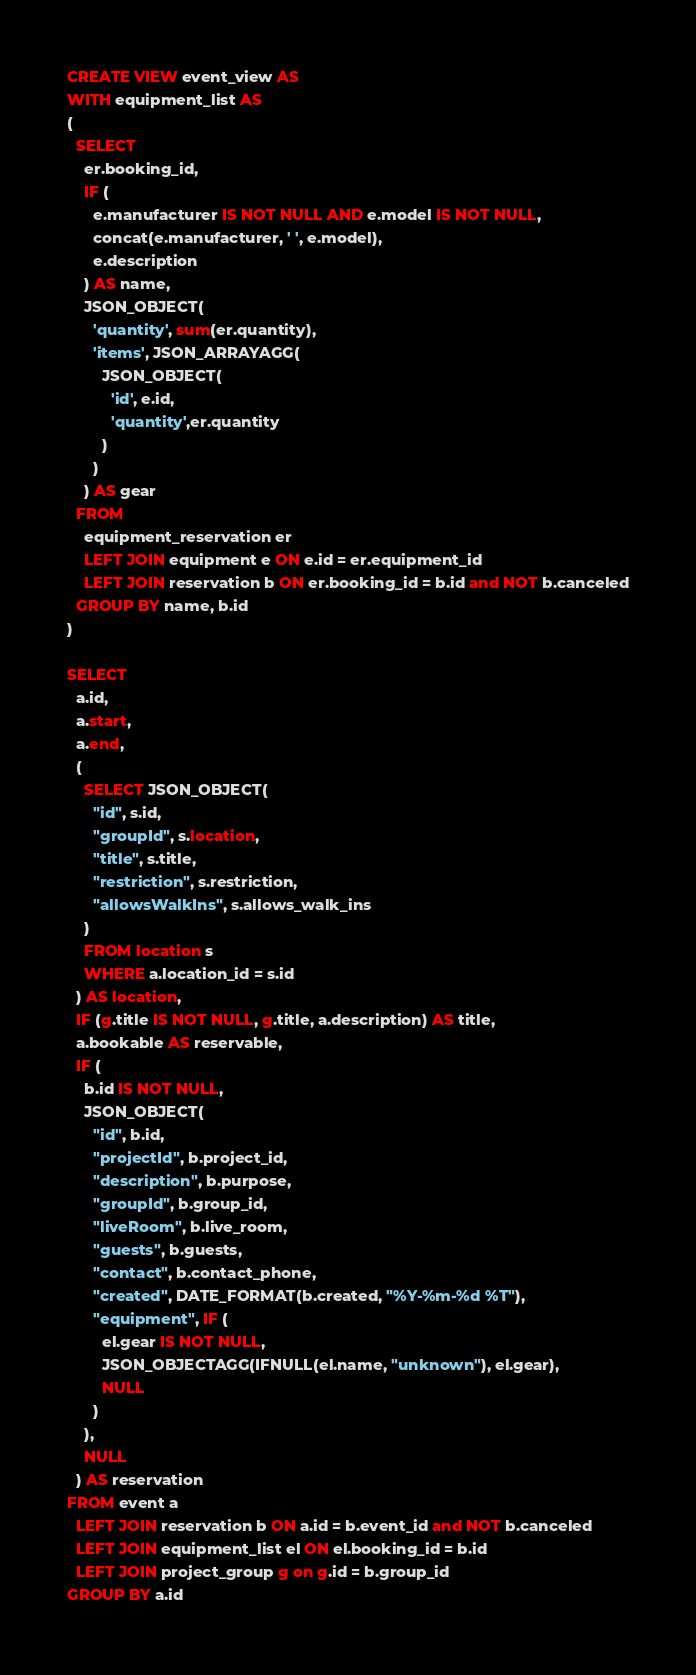<code> <loc_0><loc_0><loc_500><loc_500><_SQL_>CREATE VIEW event_view AS
WITH equipment_list AS
(
  SELECT
    er.booking_id,
    IF (
      e.manufacturer IS NOT NULL AND e.model IS NOT NULL,
      concat(e.manufacturer, ' ', e.model),
      e.description
    ) AS name,
    JSON_OBJECT(
      'quantity', sum(er.quantity),
      'items', JSON_ARRAYAGG(
        JSON_OBJECT(
          'id', e.id,
          'quantity',er.quantity
        )
      )
    ) AS gear
  FROM
    equipment_reservation er
    LEFT JOIN equipment e ON e.id = er.equipment_id
    LEFT JOIN reservation b ON er.booking_id = b.id and NOT b.canceled
  GROUP BY name, b.id
)

SELECT
  a.id,
  a.start,
  a.end,
  (
    SELECT JSON_OBJECT(
      "id", s.id,
      "groupId", s.location,
      "title", s.title,
      "restriction", s.restriction,
      "allowsWalkIns", s.allows_walk_ins
    )
    FROM location s
    WHERE a.location_id = s.id
  ) AS location,
  IF (g.title IS NOT NULL, g.title, a.description) AS title,
  a.bookable AS reservable,
  IF (
    b.id IS NOT NULL,
    JSON_OBJECT(
      "id", b.id,
      "projectId", b.project_id,
      "description", b.purpose,
      "groupId", b.group_id,
      "liveRoom", b.live_room,
      "guests", b.guests,
      "contact", b.contact_phone,
      "created", DATE_FORMAT(b.created, "%Y-%m-%d %T"),
      "equipment", IF (
        el.gear IS NOT NULL,
        JSON_OBJECTAGG(IFNULL(el.name, "unknown"), el.gear),
        NULL
      )
    ),
    NULL
  ) AS reservation
FROM event a
  LEFT JOIN reservation b ON a.id = b.event_id and NOT b.canceled
  LEFT JOIN equipment_list el ON el.booking_id = b.id
  LEFT JOIN project_group g on g.id = b.group_id
GROUP BY a.id</code> 